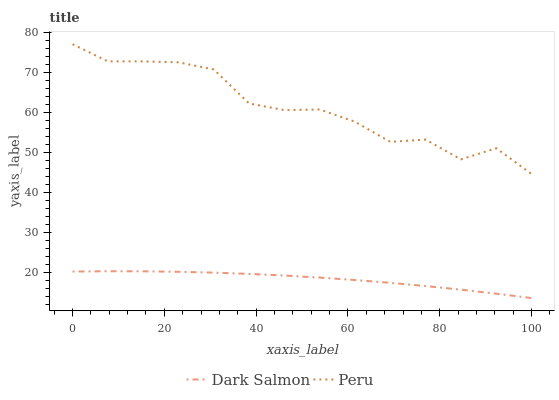Does Dark Salmon have the minimum area under the curve?
Answer yes or no. Yes. Does Peru have the maximum area under the curve?
Answer yes or no. Yes. Does Peru have the minimum area under the curve?
Answer yes or no. No. Is Dark Salmon the smoothest?
Answer yes or no. Yes. Is Peru the roughest?
Answer yes or no. Yes. Is Peru the smoothest?
Answer yes or no. No. Does Dark Salmon have the lowest value?
Answer yes or no. Yes. Does Peru have the lowest value?
Answer yes or no. No. Does Peru have the highest value?
Answer yes or no. Yes. Is Dark Salmon less than Peru?
Answer yes or no. Yes. Is Peru greater than Dark Salmon?
Answer yes or no. Yes. Does Dark Salmon intersect Peru?
Answer yes or no. No. 